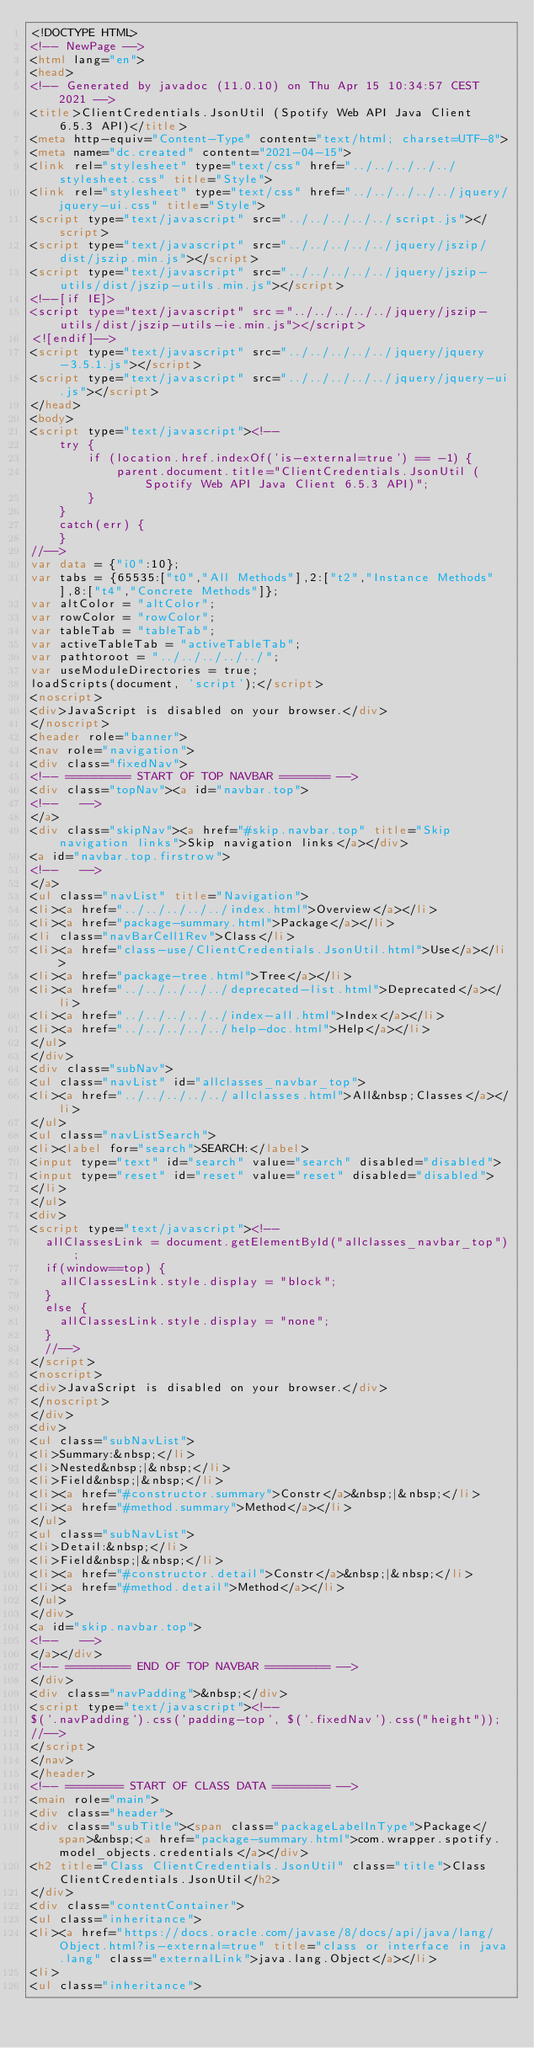<code> <loc_0><loc_0><loc_500><loc_500><_HTML_><!DOCTYPE HTML>
<!-- NewPage -->
<html lang="en">
<head>
<!-- Generated by javadoc (11.0.10) on Thu Apr 15 10:34:57 CEST 2021 -->
<title>ClientCredentials.JsonUtil (Spotify Web API Java Client 6.5.3 API)</title>
<meta http-equiv="Content-Type" content="text/html; charset=UTF-8">
<meta name="dc.created" content="2021-04-15">
<link rel="stylesheet" type="text/css" href="../../../../../stylesheet.css" title="Style">
<link rel="stylesheet" type="text/css" href="../../../../../jquery/jquery-ui.css" title="Style">
<script type="text/javascript" src="../../../../../script.js"></script>
<script type="text/javascript" src="../../../../../jquery/jszip/dist/jszip.min.js"></script>
<script type="text/javascript" src="../../../../../jquery/jszip-utils/dist/jszip-utils.min.js"></script>
<!--[if IE]>
<script type="text/javascript" src="../../../../../jquery/jszip-utils/dist/jszip-utils-ie.min.js"></script>
<![endif]-->
<script type="text/javascript" src="../../../../../jquery/jquery-3.5.1.js"></script>
<script type="text/javascript" src="../../../../../jquery/jquery-ui.js"></script>
</head>
<body>
<script type="text/javascript"><!--
    try {
        if (location.href.indexOf('is-external=true') == -1) {
            parent.document.title="ClientCredentials.JsonUtil (Spotify Web API Java Client 6.5.3 API)";
        }
    }
    catch(err) {
    }
//-->
var data = {"i0":10};
var tabs = {65535:["t0","All Methods"],2:["t2","Instance Methods"],8:["t4","Concrete Methods"]};
var altColor = "altColor";
var rowColor = "rowColor";
var tableTab = "tableTab";
var activeTableTab = "activeTableTab";
var pathtoroot = "../../../../../";
var useModuleDirectories = true;
loadScripts(document, 'script');</script>
<noscript>
<div>JavaScript is disabled on your browser.</div>
</noscript>
<header role="banner">
<nav role="navigation">
<div class="fixedNav">
<!-- ========= START OF TOP NAVBAR ======= -->
<div class="topNav"><a id="navbar.top">
<!--   -->
</a>
<div class="skipNav"><a href="#skip.navbar.top" title="Skip navigation links">Skip navigation links</a></div>
<a id="navbar.top.firstrow">
<!--   -->
</a>
<ul class="navList" title="Navigation">
<li><a href="../../../../../index.html">Overview</a></li>
<li><a href="package-summary.html">Package</a></li>
<li class="navBarCell1Rev">Class</li>
<li><a href="class-use/ClientCredentials.JsonUtil.html">Use</a></li>
<li><a href="package-tree.html">Tree</a></li>
<li><a href="../../../../../deprecated-list.html">Deprecated</a></li>
<li><a href="../../../../../index-all.html">Index</a></li>
<li><a href="../../../../../help-doc.html">Help</a></li>
</ul>
</div>
<div class="subNav">
<ul class="navList" id="allclasses_navbar_top">
<li><a href="../../../../../allclasses.html">All&nbsp;Classes</a></li>
</ul>
<ul class="navListSearch">
<li><label for="search">SEARCH:</label>
<input type="text" id="search" value="search" disabled="disabled">
<input type="reset" id="reset" value="reset" disabled="disabled">
</li>
</ul>
<div>
<script type="text/javascript"><!--
  allClassesLink = document.getElementById("allclasses_navbar_top");
  if(window==top) {
    allClassesLink.style.display = "block";
  }
  else {
    allClassesLink.style.display = "none";
  }
  //-->
</script>
<noscript>
<div>JavaScript is disabled on your browser.</div>
</noscript>
</div>
<div>
<ul class="subNavList">
<li>Summary:&nbsp;</li>
<li>Nested&nbsp;|&nbsp;</li>
<li>Field&nbsp;|&nbsp;</li>
<li><a href="#constructor.summary">Constr</a>&nbsp;|&nbsp;</li>
<li><a href="#method.summary">Method</a></li>
</ul>
<ul class="subNavList">
<li>Detail:&nbsp;</li>
<li>Field&nbsp;|&nbsp;</li>
<li><a href="#constructor.detail">Constr</a>&nbsp;|&nbsp;</li>
<li><a href="#method.detail">Method</a></li>
</ul>
</div>
<a id="skip.navbar.top">
<!--   -->
</a></div>
<!-- ========= END OF TOP NAVBAR ========= -->
</div>
<div class="navPadding">&nbsp;</div>
<script type="text/javascript"><!--
$('.navPadding').css('padding-top', $('.fixedNav').css("height"));
//-->
</script>
</nav>
</header>
<!-- ======== START OF CLASS DATA ======== -->
<main role="main">
<div class="header">
<div class="subTitle"><span class="packageLabelInType">Package</span>&nbsp;<a href="package-summary.html">com.wrapper.spotify.model_objects.credentials</a></div>
<h2 title="Class ClientCredentials.JsonUtil" class="title">Class ClientCredentials.JsonUtil</h2>
</div>
<div class="contentContainer">
<ul class="inheritance">
<li><a href="https://docs.oracle.com/javase/8/docs/api/java/lang/Object.html?is-external=true" title="class or interface in java.lang" class="externalLink">java.lang.Object</a></li>
<li>
<ul class="inheritance"></code> 